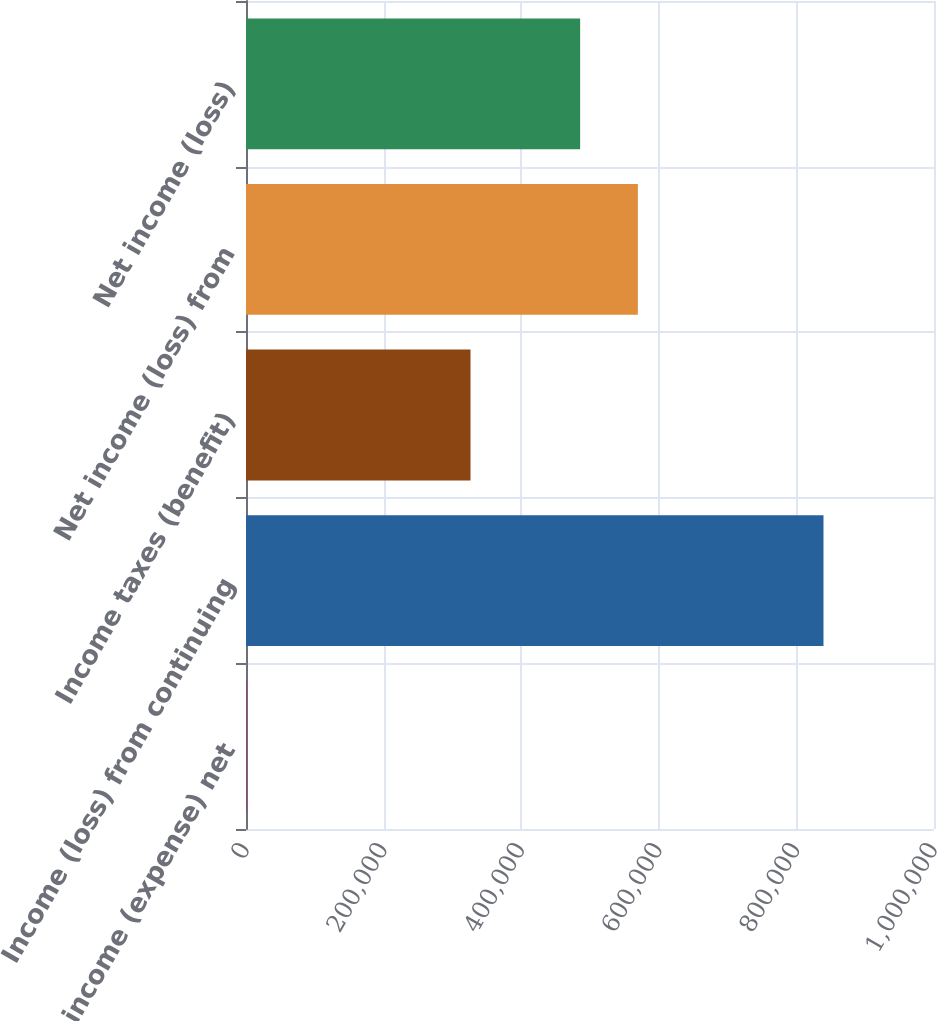Convert chart. <chart><loc_0><loc_0><loc_500><loc_500><bar_chart><fcel>Other income (expense) net<fcel>Income (loss) from continuing<fcel>Income taxes (benefit)<fcel>Net income (loss) from<fcel>Net income (loss)<nl><fcel>501<fcel>839370<fcel>326315<fcel>569560<fcel>485673<nl></chart> 